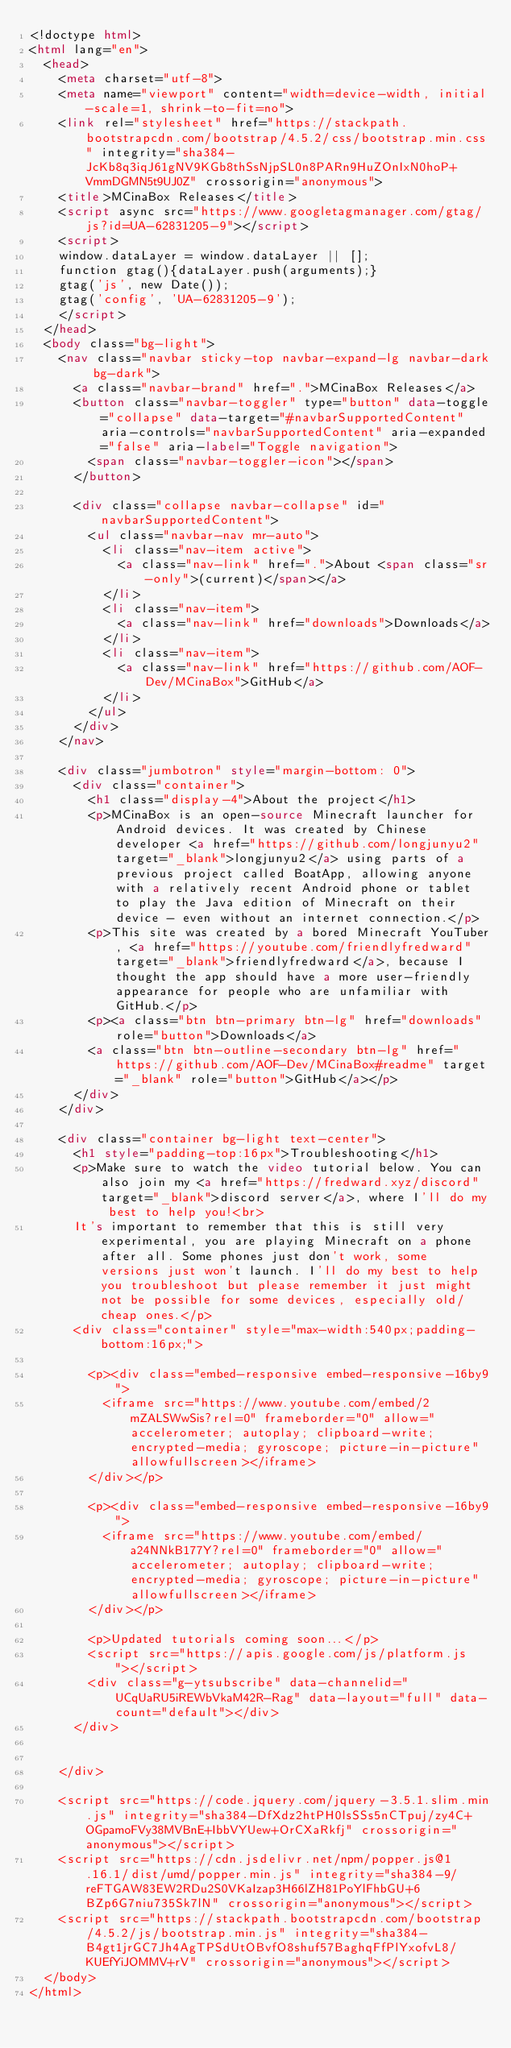<code> <loc_0><loc_0><loc_500><loc_500><_HTML_><!doctype html>
<html lang="en">
	<head>
		<meta charset="utf-8">
		<meta name="viewport" content="width=device-width, initial-scale=1, shrink-to-fit=no">
		<link rel="stylesheet" href="https://stackpath.bootstrapcdn.com/bootstrap/4.5.2/css/bootstrap.min.css" integrity="sha384-JcKb8q3iqJ61gNV9KGb8thSsNjpSL0n8PARn9HuZOnIxN0hoP+VmmDGMN5t9UJ0Z" crossorigin="anonymous">
		<title>MCinaBox Releases</title>
		<script async src="https://www.googletagmanager.com/gtag/js?id=UA-62831205-9"></script>
		<script>
		window.dataLayer = window.dataLayer || [];
		function gtag(){dataLayer.push(arguments);}
		gtag('js', new Date());
		gtag('config', 'UA-62831205-9');
		</script>
	</head>
	<body class="bg-light">
		<nav class="navbar sticky-top navbar-expand-lg navbar-dark bg-dark">
			<a class="navbar-brand" href=".">MCinaBox Releases</a>
			<button class="navbar-toggler" type="button" data-toggle="collapse" data-target="#navbarSupportedContent" aria-controls="navbarSupportedContent" aria-expanded="false" aria-label="Toggle navigation">
				<span class="navbar-toggler-icon"></span>
			</button>

			<div class="collapse navbar-collapse" id="navbarSupportedContent">
				<ul class="navbar-nav mr-auto">
					<li class="nav-item active">
						<a class="nav-link" href=".">About <span class="sr-only">(current)</span></a>
					</li>
					<li class="nav-item">
						<a class="nav-link" href="downloads">Downloads</a>
					</li>
					<li class="nav-item">
						<a class="nav-link" href="https://github.com/AOF-Dev/MCinaBox">GitHub</a>
					</li>
				</ul>
			</div>
		</nav>
		
		<div class="jumbotron" style="margin-bottom: 0">
			<div class="container">
				<h1 class="display-4">About the project</h1>
				<p>MCinaBox is an open-source Minecraft launcher for Android devices. It was created by Chinese developer <a href="https://github.com/longjunyu2" target="_blank">longjunyu2</a> using parts of a previous project called BoatApp, allowing anyone with a relatively recent Android phone or tablet to play the Java edition of Minecraft on their device - even without an internet connection.</p>
				<p>This site was created by a bored Minecraft YouTuber, <a href="https://youtube.com/friendlyfredward" target="_blank">friendlyfredward</a>, because I thought the app should have a more user-friendly appearance for people who are unfamiliar with GitHub.</p>
				<p><a class="btn btn-primary btn-lg" href="downloads" role="button">Downloads</a>
				<a class="btn btn-outline-secondary btn-lg" href="https://github.com/AOF-Dev/MCinaBox#readme" target="_blank" role="button">GitHub</a></p>
			</div>
		</div>
		
		<div class="container bg-light text-center">
			<h1 style="padding-top:16px">Troubleshooting</h1>
			<p>Make sure to watch the video tutorial below. You can also join my <a href="https://fredward.xyz/discord" target="_blank">discord server</a>, where I'll do my best to help you!<br>
			It's important to remember that this is still very experimental, you are playing Minecraft on a phone after all. Some phones just don't work, some versions just won't launch. I'll do my best to help you troubleshoot but please remember it just might not be possible for some devices, especially old/cheap ones.</p>
			<div class="container" style="max-width:540px;padding-bottom:16px;">
				
				<p><div class="embed-responsive embed-responsive-16by9">
					<iframe src="https://www.youtube.com/embed/2mZALSWwSis?rel=0" frameborder="0" allow="accelerometer; autoplay; clipboard-write; encrypted-media; gyroscope; picture-in-picture" allowfullscreen></iframe>
				</div></p>
				
				<p><div class="embed-responsive embed-responsive-16by9">
					<iframe src="https://www.youtube.com/embed/a24NNkB177Y?rel=0" frameborder="0" allow="accelerometer; autoplay; clipboard-write; encrypted-media; gyroscope; picture-in-picture" allowfullscreen></iframe>
				</div></p>
				
				<p>Updated tutorials coming soon...</p>
				<script src="https://apis.google.com/js/platform.js"></script>
				<div class="g-ytsubscribe" data-channelid="UCqUaRU5iREWbVkaM42R-Rag" data-layout="full" data-count="default"></div>
			</div>
			
			
		</div>

		<script src="https://code.jquery.com/jquery-3.5.1.slim.min.js" integrity="sha384-DfXdz2htPH0lsSSs5nCTpuj/zy4C+OGpamoFVy38MVBnE+IbbVYUew+OrCXaRkfj" crossorigin="anonymous"></script>
		<script src="https://cdn.jsdelivr.net/npm/popper.js@1.16.1/dist/umd/popper.min.js" integrity="sha384-9/reFTGAW83EW2RDu2S0VKaIzap3H66lZH81PoYlFhbGU+6BZp6G7niu735Sk7lN" crossorigin="anonymous"></script>
		<script src="https://stackpath.bootstrapcdn.com/bootstrap/4.5.2/js/bootstrap.min.js" integrity="sha384-B4gt1jrGC7Jh4AgTPSdUtOBvfO8shuf57BaghqFfPlYxofvL8/KUEfYiJOMMV+rV" crossorigin="anonymous"></script>
	</body>
</html></code> 